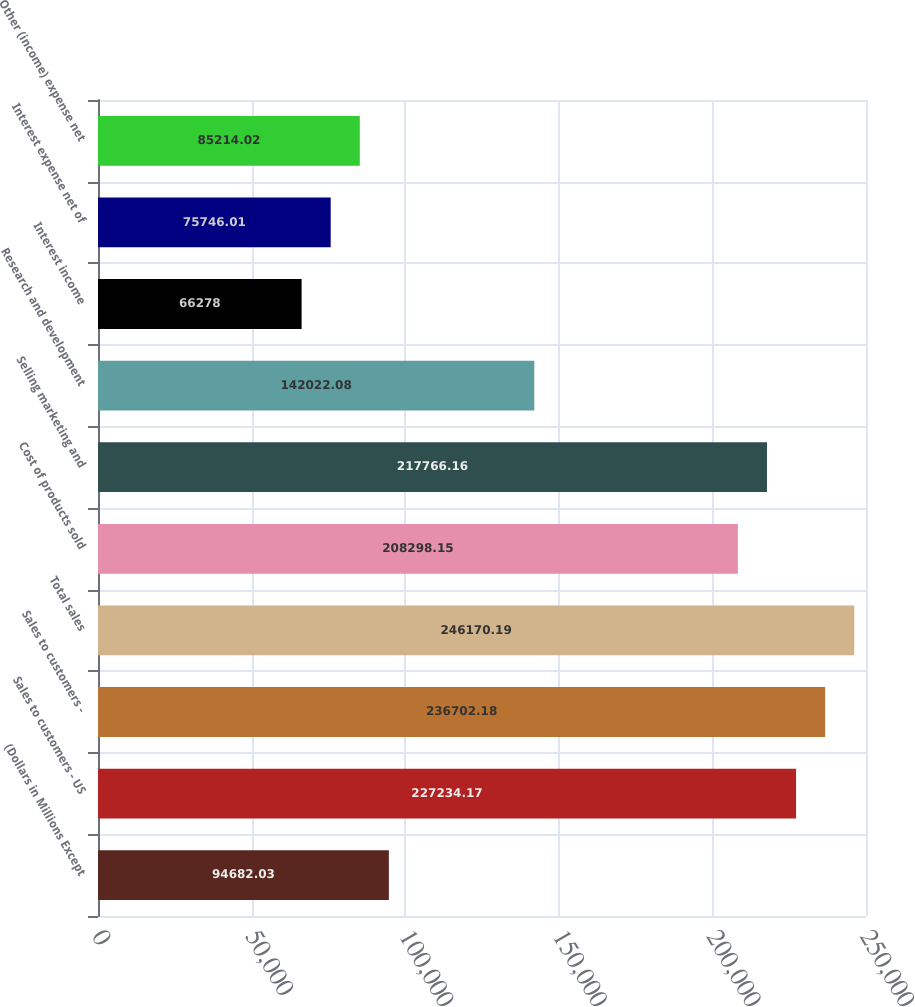Convert chart to OTSL. <chart><loc_0><loc_0><loc_500><loc_500><bar_chart><fcel>(Dollars in Millions Except<fcel>Sales to customers - US<fcel>Sales to customers -<fcel>Total sales<fcel>Cost of products sold<fcel>Selling marketing and<fcel>Research and development<fcel>Interest income<fcel>Interest expense net of<fcel>Other (income) expense net<nl><fcel>94682<fcel>227234<fcel>236702<fcel>246170<fcel>208298<fcel>217766<fcel>142022<fcel>66278<fcel>75746<fcel>85214<nl></chart> 